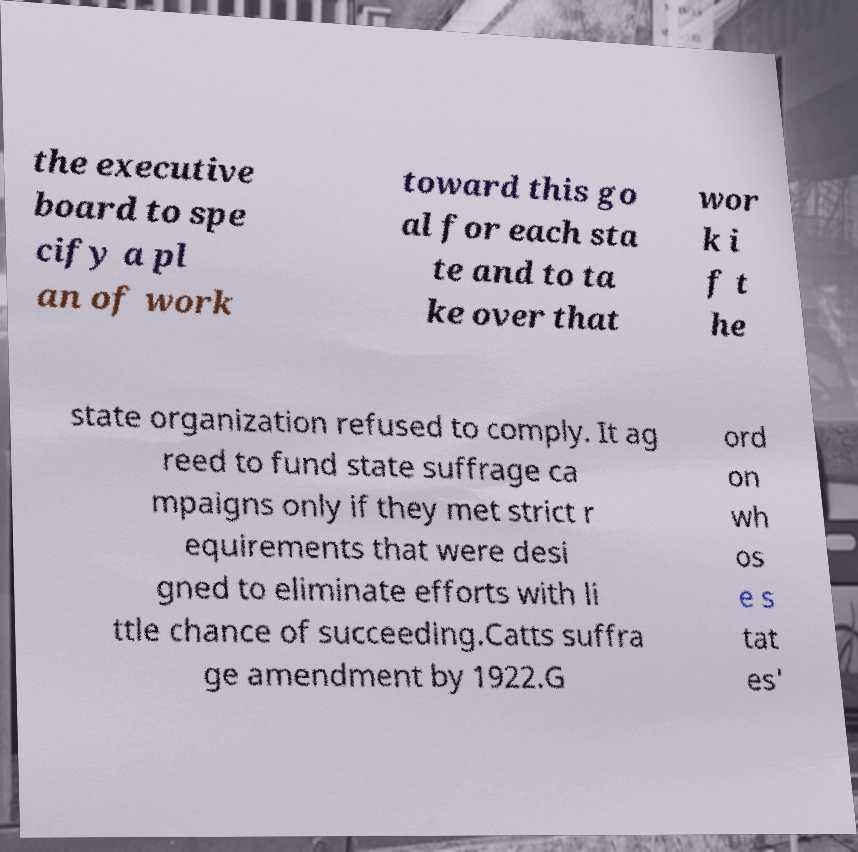Could you assist in decoding the text presented in this image and type it out clearly? the executive board to spe cify a pl an of work toward this go al for each sta te and to ta ke over that wor k i f t he state organization refused to comply. It ag reed to fund state suffrage ca mpaigns only if they met strict r equirements that were desi gned to eliminate efforts with li ttle chance of succeeding.Catts suffra ge amendment by 1922.G ord on wh os e s tat es' 